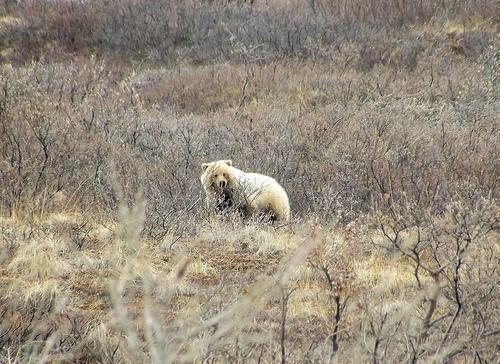How many eyes does the bear have?
Give a very brief answer. 2. How many bears are there?
Give a very brief answer. 1. 